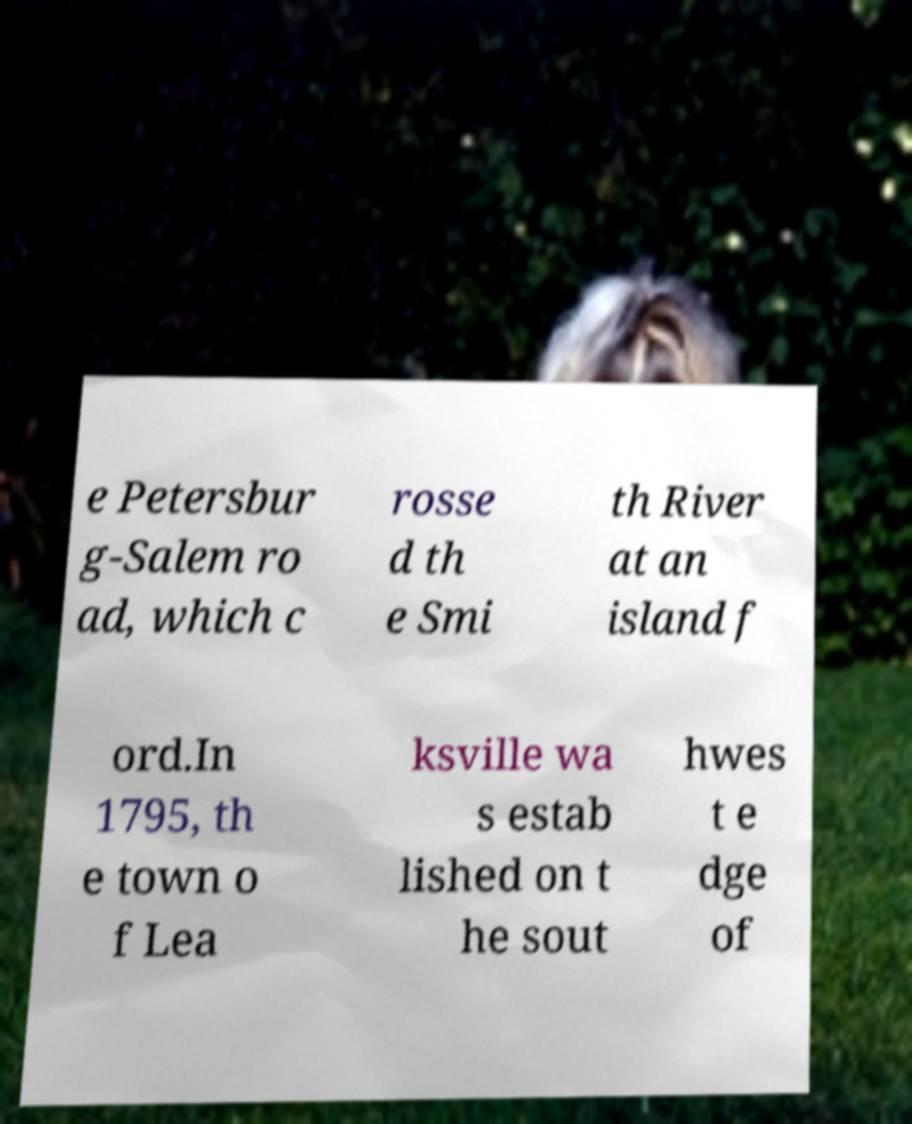There's text embedded in this image that I need extracted. Can you transcribe it verbatim? e Petersbur g-Salem ro ad, which c rosse d th e Smi th River at an island f ord.In 1795, th e town o f Lea ksville wa s estab lished on t he sout hwes t e dge of 